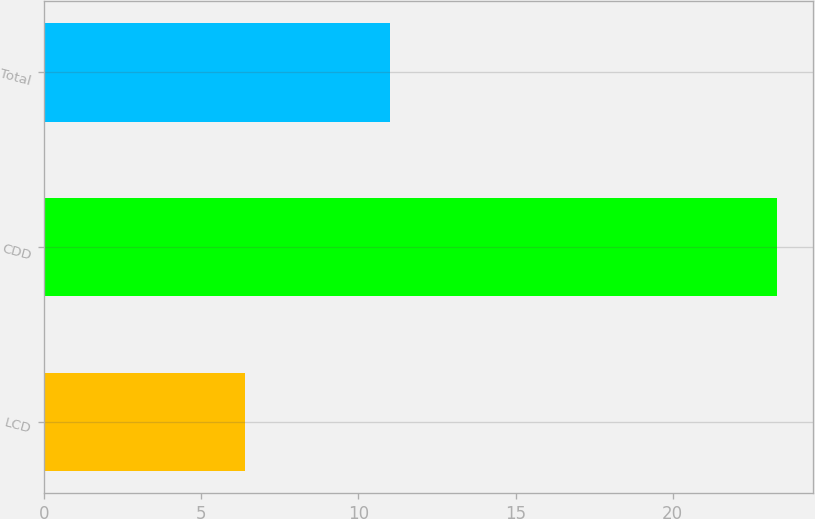<chart> <loc_0><loc_0><loc_500><loc_500><bar_chart><fcel>LCD<fcel>CDD<fcel>Total<nl><fcel>6.4<fcel>23.3<fcel>11<nl></chart> 